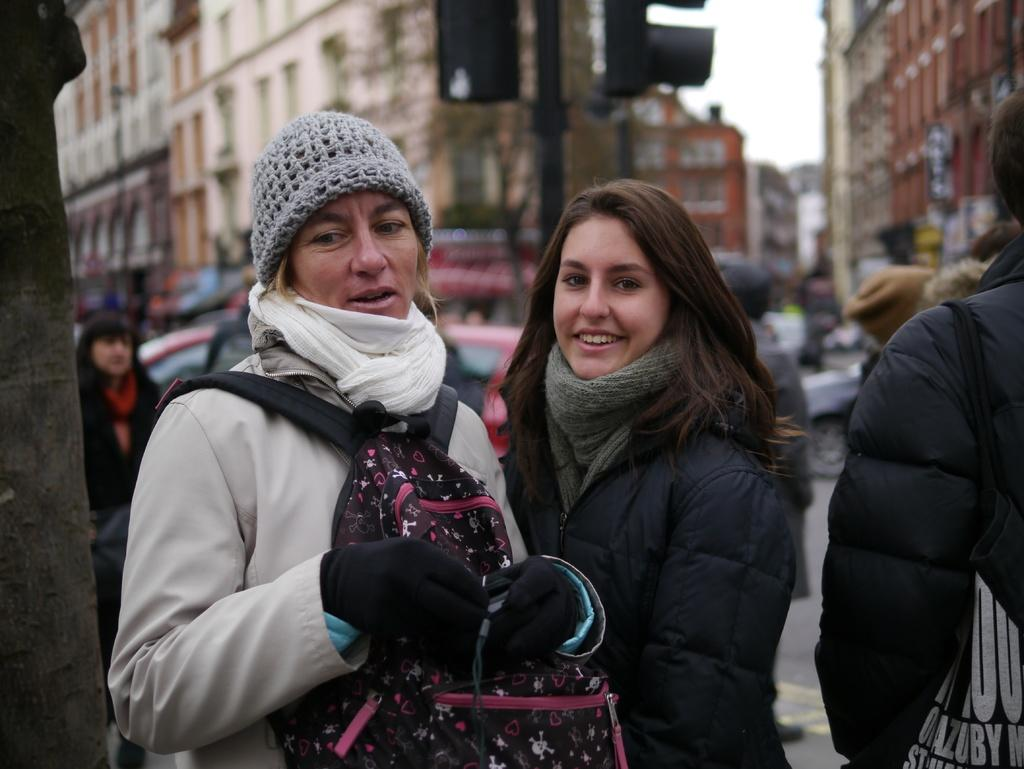What is happening in the image? There are people standing in the image. Can you describe the attire of one of the individuals? A woman is wearing a bag and cap. What can be seen in the background of the image? There is a traffic signal on a pole, buildings, people, and the sky visible in the background. How many cups of tea are being served in the image? There is no mention of cups or tea in the image; it features people standing and a woman wearing a bag and cap. What type of comfort can be found in the houses in the image? There are no houses present in the image; it features a traffic signal, buildings, people, and the sky visible in the background. 